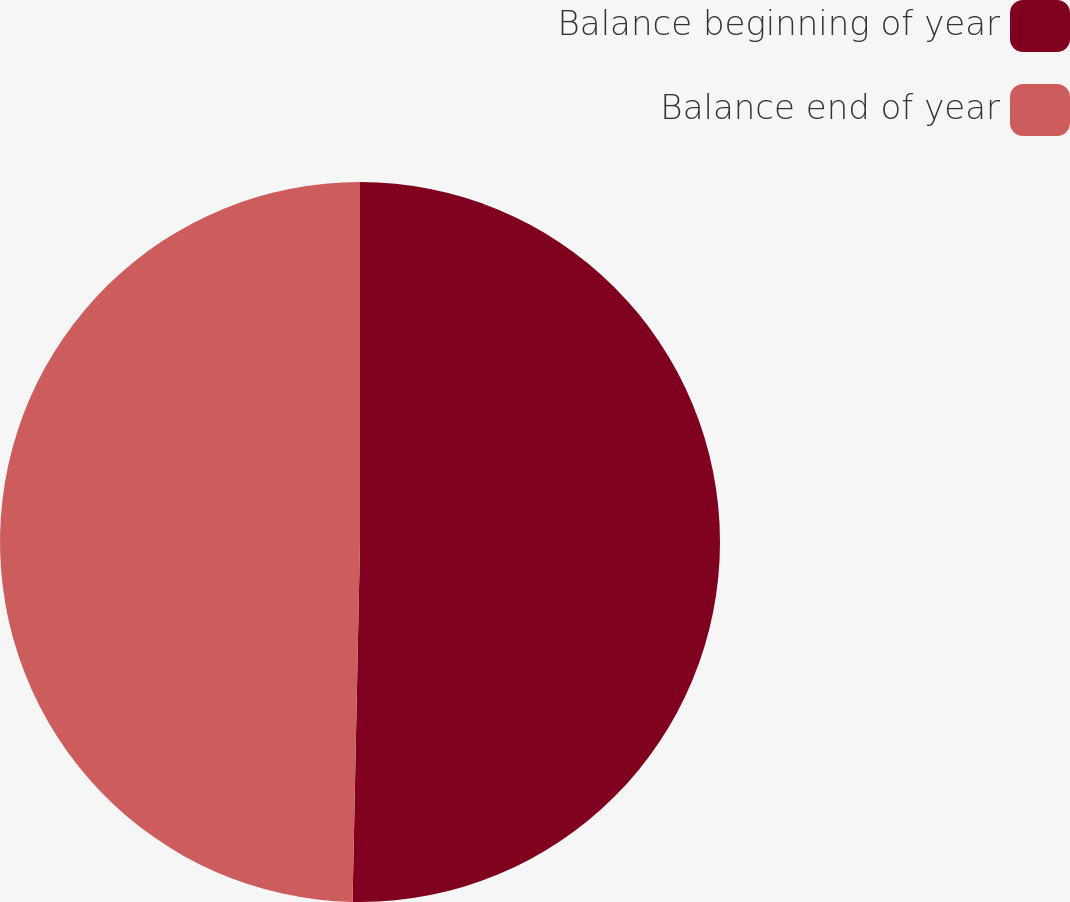Convert chart to OTSL. <chart><loc_0><loc_0><loc_500><loc_500><pie_chart><fcel>Balance beginning of year<fcel>Balance end of year<nl><fcel>50.33%<fcel>49.67%<nl></chart> 